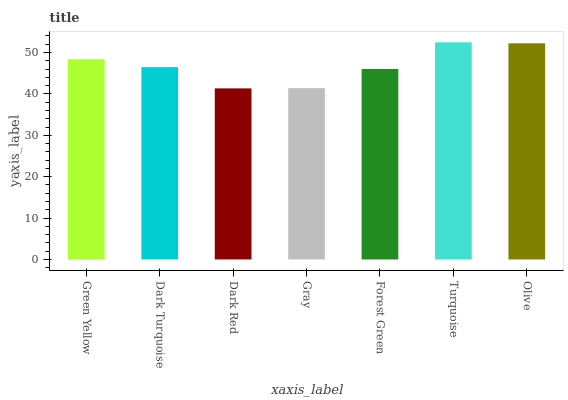Is Dark Turquoise the minimum?
Answer yes or no. No. Is Dark Turquoise the maximum?
Answer yes or no. No. Is Green Yellow greater than Dark Turquoise?
Answer yes or no. Yes. Is Dark Turquoise less than Green Yellow?
Answer yes or no. Yes. Is Dark Turquoise greater than Green Yellow?
Answer yes or no. No. Is Green Yellow less than Dark Turquoise?
Answer yes or no. No. Is Dark Turquoise the high median?
Answer yes or no. Yes. Is Dark Turquoise the low median?
Answer yes or no. Yes. Is Dark Red the high median?
Answer yes or no. No. Is Gray the low median?
Answer yes or no. No. 